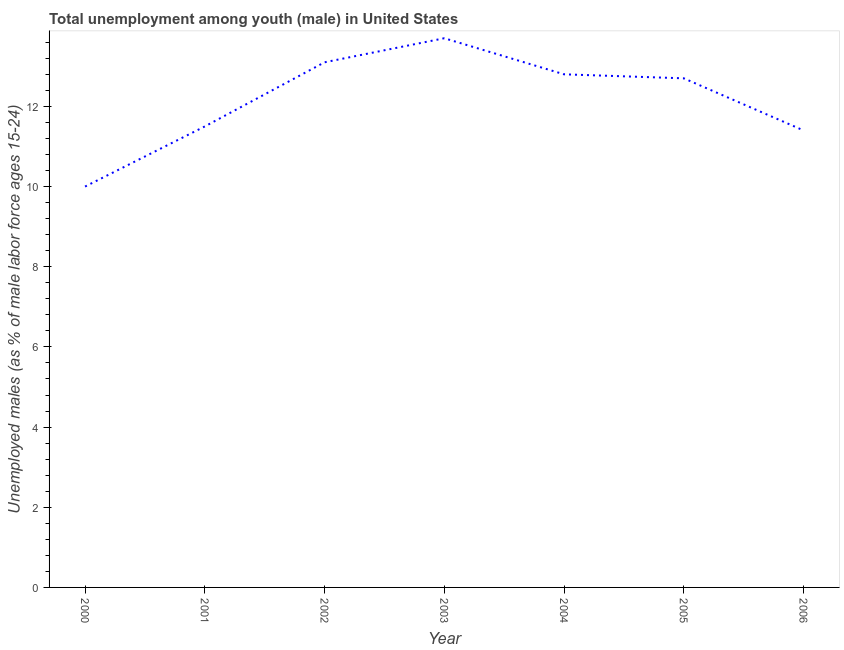What is the unemployed male youth population in 2005?
Your answer should be compact. 12.7. Across all years, what is the maximum unemployed male youth population?
Keep it short and to the point. 13.7. What is the sum of the unemployed male youth population?
Keep it short and to the point. 85.2. What is the difference between the unemployed male youth population in 2001 and 2006?
Keep it short and to the point. 0.1. What is the average unemployed male youth population per year?
Give a very brief answer. 12.17. What is the median unemployed male youth population?
Offer a terse response. 12.7. In how many years, is the unemployed male youth population greater than 0.4 %?
Your response must be concise. 7. What is the ratio of the unemployed male youth population in 2004 to that in 2006?
Provide a short and direct response. 1.12. What is the difference between the highest and the second highest unemployed male youth population?
Give a very brief answer. 0.6. Is the sum of the unemployed male youth population in 2002 and 2004 greater than the maximum unemployed male youth population across all years?
Offer a very short reply. Yes. What is the difference between the highest and the lowest unemployed male youth population?
Keep it short and to the point. 3.7. In how many years, is the unemployed male youth population greater than the average unemployed male youth population taken over all years?
Make the answer very short. 4. Does the unemployed male youth population monotonically increase over the years?
Provide a short and direct response. No. How many lines are there?
Keep it short and to the point. 1. Are the values on the major ticks of Y-axis written in scientific E-notation?
Your response must be concise. No. What is the title of the graph?
Your answer should be compact. Total unemployment among youth (male) in United States. What is the label or title of the X-axis?
Your answer should be compact. Year. What is the label or title of the Y-axis?
Your response must be concise. Unemployed males (as % of male labor force ages 15-24). What is the Unemployed males (as % of male labor force ages 15-24) in 2001?
Keep it short and to the point. 11.5. What is the Unemployed males (as % of male labor force ages 15-24) in 2002?
Provide a succinct answer. 13.1. What is the Unemployed males (as % of male labor force ages 15-24) in 2003?
Offer a terse response. 13.7. What is the Unemployed males (as % of male labor force ages 15-24) of 2004?
Provide a short and direct response. 12.8. What is the Unemployed males (as % of male labor force ages 15-24) in 2005?
Ensure brevity in your answer.  12.7. What is the Unemployed males (as % of male labor force ages 15-24) of 2006?
Provide a short and direct response. 11.4. What is the difference between the Unemployed males (as % of male labor force ages 15-24) in 2000 and 2002?
Offer a terse response. -3.1. What is the difference between the Unemployed males (as % of male labor force ages 15-24) in 2000 and 2003?
Your response must be concise. -3.7. What is the difference between the Unemployed males (as % of male labor force ages 15-24) in 2000 and 2005?
Keep it short and to the point. -2.7. What is the difference between the Unemployed males (as % of male labor force ages 15-24) in 2000 and 2006?
Provide a short and direct response. -1.4. What is the difference between the Unemployed males (as % of male labor force ages 15-24) in 2001 and 2003?
Keep it short and to the point. -2.2. What is the difference between the Unemployed males (as % of male labor force ages 15-24) in 2001 and 2004?
Offer a terse response. -1.3. What is the difference between the Unemployed males (as % of male labor force ages 15-24) in 2001 and 2006?
Offer a very short reply. 0.1. What is the difference between the Unemployed males (as % of male labor force ages 15-24) in 2002 and 2003?
Your answer should be very brief. -0.6. What is the difference between the Unemployed males (as % of male labor force ages 15-24) in 2002 and 2004?
Your answer should be very brief. 0.3. What is the difference between the Unemployed males (as % of male labor force ages 15-24) in 2002 and 2005?
Provide a short and direct response. 0.4. What is the difference between the Unemployed males (as % of male labor force ages 15-24) in 2003 and 2004?
Your response must be concise. 0.9. What is the difference between the Unemployed males (as % of male labor force ages 15-24) in 2003 and 2005?
Offer a terse response. 1. What is the difference between the Unemployed males (as % of male labor force ages 15-24) in 2004 and 2006?
Your answer should be very brief. 1.4. What is the ratio of the Unemployed males (as % of male labor force ages 15-24) in 2000 to that in 2001?
Offer a terse response. 0.87. What is the ratio of the Unemployed males (as % of male labor force ages 15-24) in 2000 to that in 2002?
Your response must be concise. 0.76. What is the ratio of the Unemployed males (as % of male labor force ages 15-24) in 2000 to that in 2003?
Offer a very short reply. 0.73. What is the ratio of the Unemployed males (as % of male labor force ages 15-24) in 2000 to that in 2004?
Ensure brevity in your answer.  0.78. What is the ratio of the Unemployed males (as % of male labor force ages 15-24) in 2000 to that in 2005?
Your answer should be compact. 0.79. What is the ratio of the Unemployed males (as % of male labor force ages 15-24) in 2000 to that in 2006?
Your response must be concise. 0.88. What is the ratio of the Unemployed males (as % of male labor force ages 15-24) in 2001 to that in 2002?
Provide a short and direct response. 0.88. What is the ratio of the Unemployed males (as % of male labor force ages 15-24) in 2001 to that in 2003?
Keep it short and to the point. 0.84. What is the ratio of the Unemployed males (as % of male labor force ages 15-24) in 2001 to that in 2004?
Provide a short and direct response. 0.9. What is the ratio of the Unemployed males (as % of male labor force ages 15-24) in 2001 to that in 2005?
Offer a terse response. 0.91. What is the ratio of the Unemployed males (as % of male labor force ages 15-24) in 2001 to that in 2006?
Keep it short and to the point. 1.01. What is the ratio of the Unemployed males (as % of male labor force ages 15-24) in 2002 to that in 2003?
Your answer should be compact. 0.96. What is the ratio of the Unemployed males (as % of male labor force ages 15-24) in 2002 to that in 2004?
Provide a succinct answer. 1.02. What is the ratio of the Unemployed males (as % of male labor force ages 15-24) in 2002 to that in 2005?
Offer a very short reply. 1.03. What is the ratio of the Unemployed males (as % of male labor force ages 15-24) in 2002 to that in 2006?
Offer a very short reply. 1.15. What is the ratio of the Unemployed males (as % of male labor force ages 15-24) in 2003 to that in 2004?
Keep it short and to the point. 1.07. What is the ratio of the Unemployed males (as % of male labor force ages 15-24) in 2003 to that in 2005?
Offer a terse response. 1.08. What is the ratio of the Unemployed males (as % of male labor force ages 15-24) in 2003 to that in 2006?
Make the answer very short. 1.2. What is the ratio of the Unemployed males (as % of male labor force ages 15-24) in 2004 to that in 2005?
Your answer should be compact. 1.01. What is the ratio of the Unemployed males (as % of male labor force ages 15-24) in 2004 to that in 2006?
Provide a succinct answer. 1.12. What is the ratio of the Unemployed males (as % of male labor force ages 15-24) in 2005 to that in 2006?
Your answer should be compact. 1.11. 